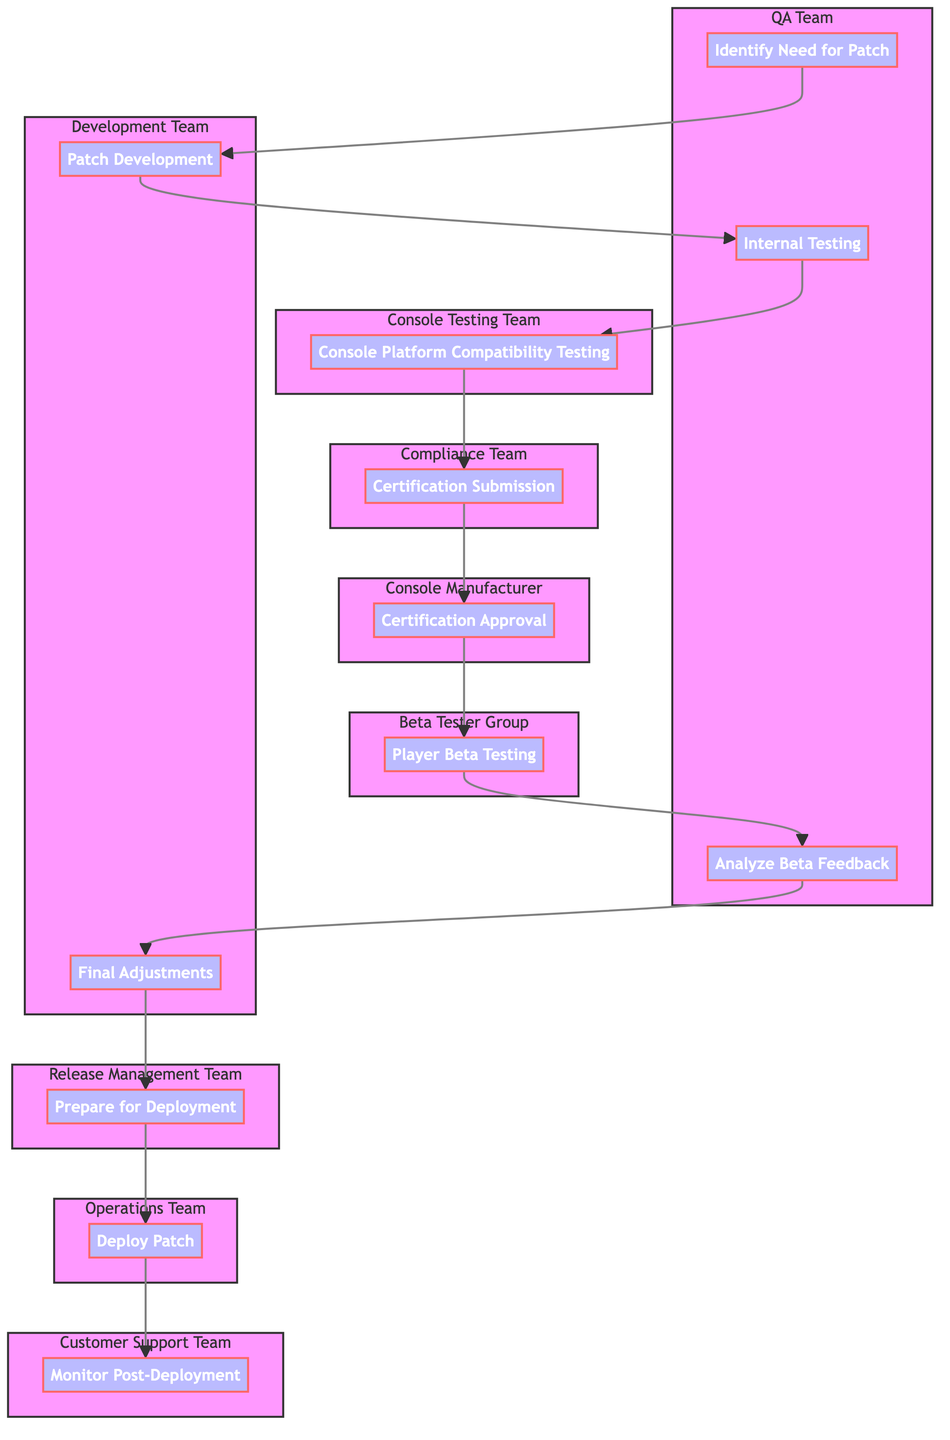What is the first step in the Patch Update Deployment Cycle? The first step in the cycle, as indicated in the flow chart, is "Identify Need for Patch." This is the starting point where the QA Team analyzes feedback and metrics.
Answer: Identify Need for Patch How many total steps are there in the Patch Update Deployment Cycle? By counting the nodes in the flow chart, there are 12 steps in total, including all processes from identifying the need for a patch to monitoring post-deployment.
Answer: 12 Which team is responsible for the "Certification Submission"? In the flow chart, the "Certification Submission" step is handled by the Compliance Team, which is clearly labeled in the diagram.
Answer: Compliance Team What occurs immediately after "Player Beta Testing"? Following "Player Beta Testing," the next step shown in the flow chart is "Analyze Beta Feedback," indicating the process of collecting feedback from beta testers.
Answer: Analyze Beta Feedback Which step involves submitting the patch for approval? The step involving submission for approval is "Certification Submission." This is where the Compliance Team takes action to submit the patch.
Answer: Certification Submission What is the role of the "Customer Support Team" in the deployment cycle? In the diagram, the Customer Support Team is responsible for the step titled "Monitor Post-Deployment," which indicates they monitor performance and feedback after the patch is live.
Answer: Monitor Post-Deployment How many teams are involved in the Patch Update Deployment Cycle? There are 8 distinct teams mentioned throughout the flowchart, each associated with specific steps in the cycle.
Answer: 8 What happens if the patch fails certification? While the diagram does not explicitly address this scenario, the failure to receive "Certification Approval" would likely require revisiting earlier steps, such as "Patch Development" or "Certification Submission." The general implication is that the process would loop back for necessary changes before resubmission.
Answer: Revisit earlier steps Which step comes directly before "Deploy Patch"? The step directly preceding "Deploy Patch" is "Prepare for Deployment." This indicates that final preparations are made immediately before releasing the patch to players.
Answer: Prepare for Deployment What is the last step in the Patch Update Deployment Cycle? According to the flowchart, the last step is "Monitor Post-Deployment," which completes the cycle by ensuring ongoing performance oversight after the patch is deployed.
Answer: Monitor Post-Deployment 